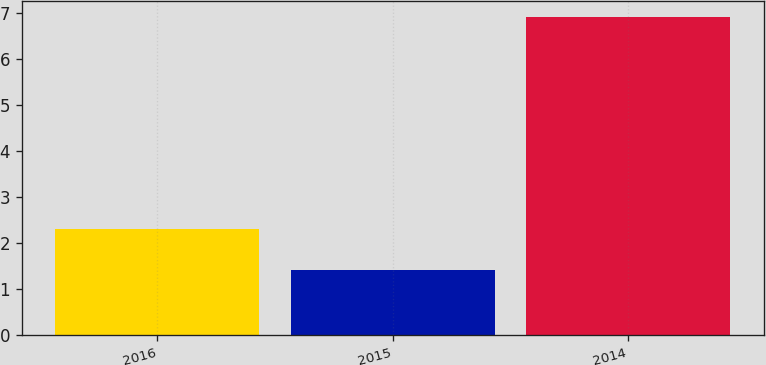Convert chart to OTSL. <chart><loc_0><loc_0><loc_500><loc_500><bar_chart><fcel>2016<fcel>2015<fcel>2014<nl><fcel>2.3<fcel>1.4<fcel>6.9<nl></chart> 